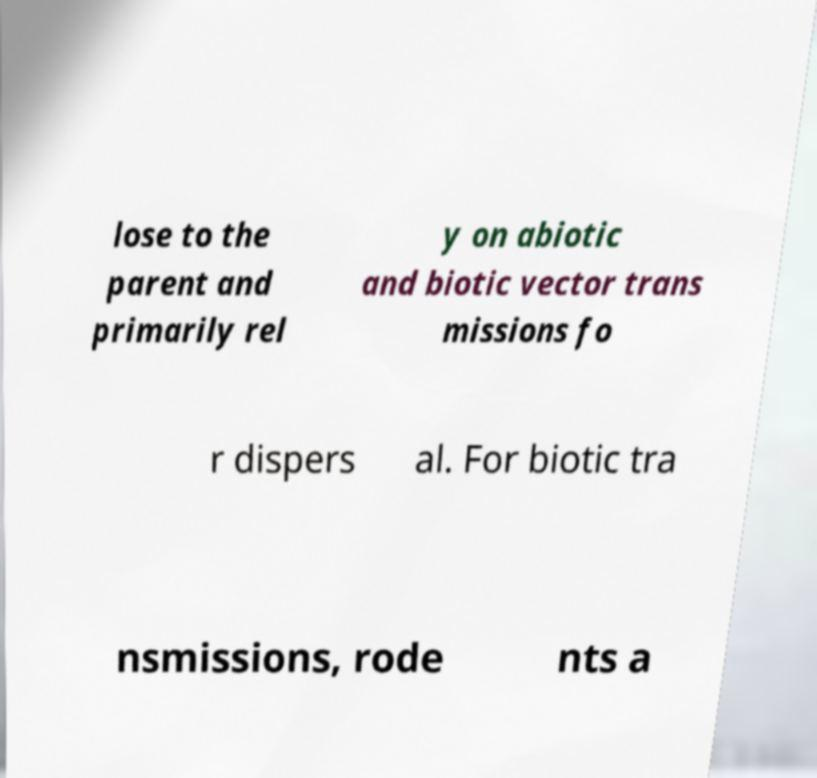For documentation purposes, I need the text within this image transcribed. Could you provide that? lose to the parent and primarily rel y on abiotic and biotic vector trans missions fo r dispers al. For biotic tra nsmissions, rode nts a 